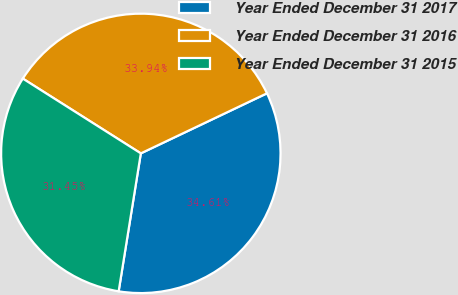Convert chart. <chart><loc_0><loc_0><loc_500><loc_500><pie_chart><fcel>Year Ended December 31 2017<fcel>Year Ended December 31 2016<fcel>Year Ended December 31 2015<nl><fcel>34.61%<fcel>33.94%<fcel>31.45%<nl></chart> 